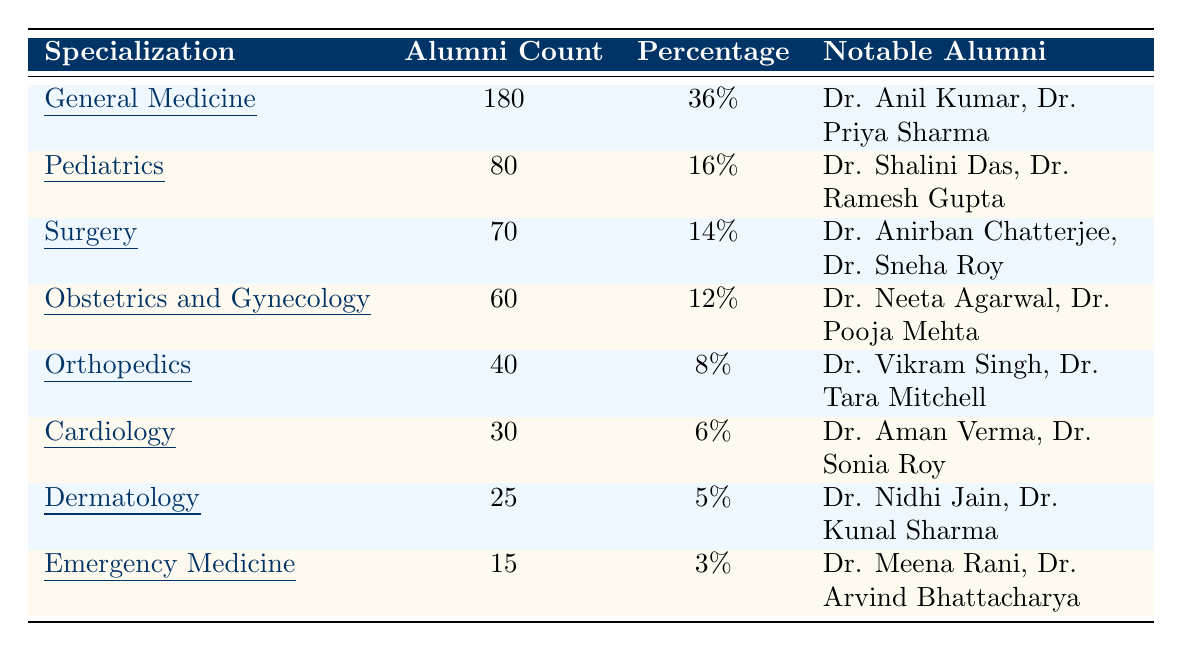What is the specialization with the highest number of alumni? The table shows that General Medicine has the highest alumni count with 180.
Answer: General Medicine What percentage of alumni specialize in Cardiology? According to the table, 6% of alumni specialize in Cardiology.
Answer: 6% How many more alumni are in General Medicine compared to Emergency Medicine? General Medicine has 180 alumni and Emergency Medicine has 15. The difference is 180 - 15 = 165.
Answer: 165 Which two specializations have the least number of alumni? The table lists Dermatology with 25 alumni and Emergency Medicine with 15 alumni, making them the two specializations with the least alumni.
Answer: Dermatology and Emergency Medicine What percentage do the alumni counts of Pediatrics and Surgery together represent? Pediatrics has 80 alumni (16%) and Surgery has 70 alumni (14%). Together, they have 80 + 70 = 150 alumni, which is 30% of the total alumni (500).
Answer: 30% Is it true that Obstetrics and Gynecology has more alumni than Orthopedics? The table shows Obstetrics and Gynecology has 60 alumni and Orthopedics has 40 alumni, so yes, it is true.
Answer: Yes If you consider the three specializations with the most alumni, what percentage of the total alumni do they represent? The top three specializations are General Medicine (36%), Pediatrics (16%), and Surgery (14%), totaling 36 + 16 + 14 = 66%.
Answer: 66% How many alumni specialize in either Dermatology or Emergency Medicine? The table indicates 25 alumni in Dermatology and 15 in Emergency Medicine, totaling 25 + 15 = 40 alumni.
Answer: 40 What is the ratio of alumni in Orthopedics to those in Emergency Medicine? Orthopedics has 40 alumni, while Emergency Medicine has 15. The ratio is 40:15, which simplifies to 8:3.
Answer: 8:3 Which notable alumni are associated with Surgery? The table lists Dr. Anirban Chatterjee and Dr. Sneha Roy as notable alumni for Surgery.
Answer: Dr. Anirban Chatterjee, Dr. Sneha Roy 